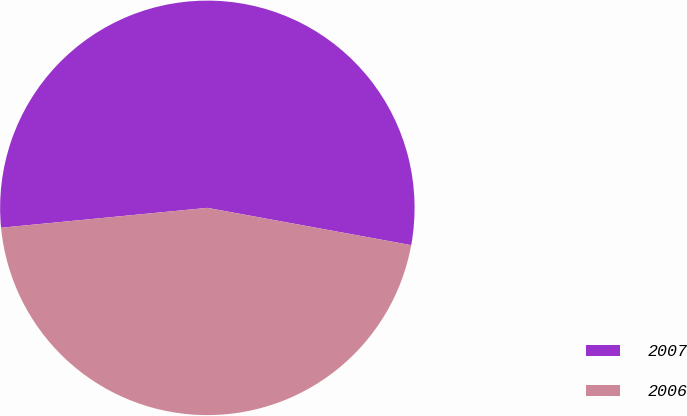<chart> <loc_0><loc_0><loc_500><loc_500><pie_chart><fcel>2007<fcel>2006<nl><fcel>54.41%<fcel>45.59%<nl></chart> 